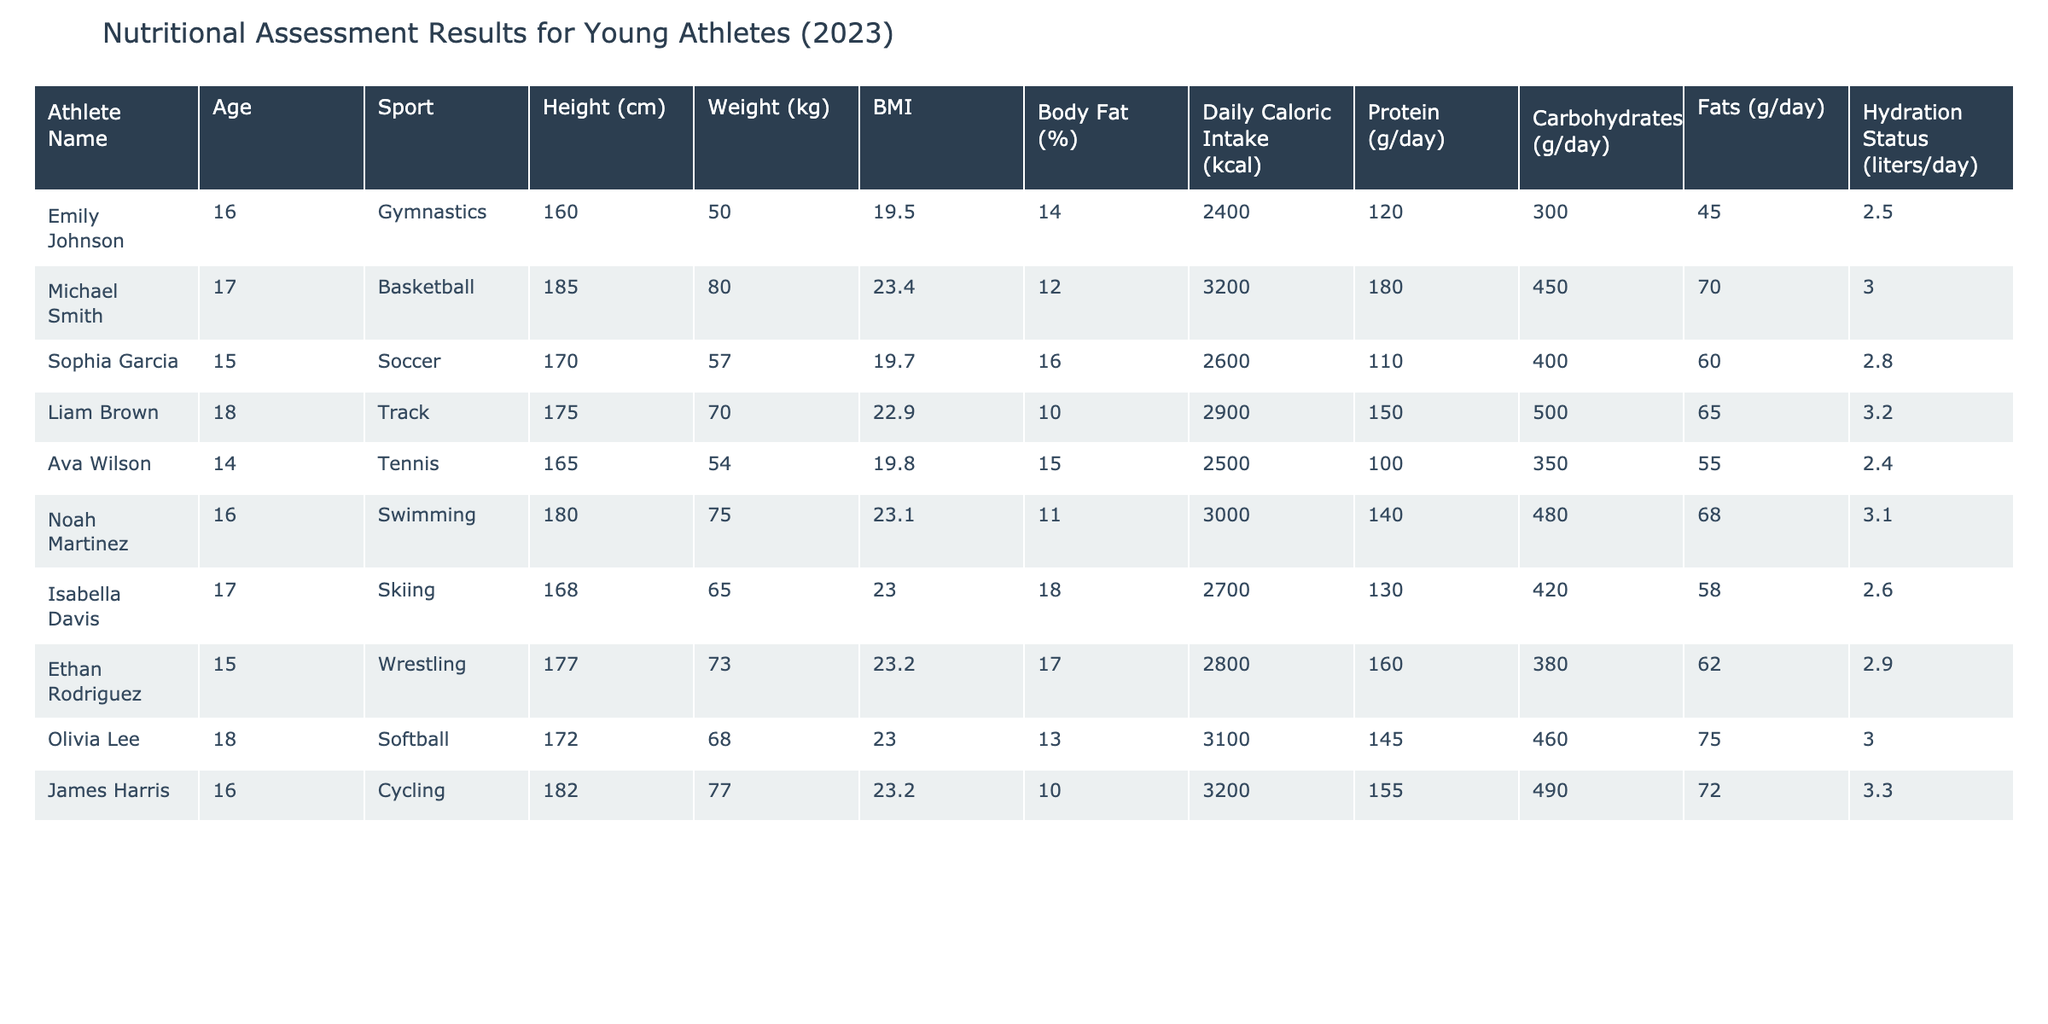What is the BMI of Noah Martinez? The BMI (Body Mass Index) is listed directly in the table for each athlete. For Noah Martinez, it is noted as 23.1.
Answer: 23.1 What is the average daily caloric intake for all athletes in the table? To find the average daily caloric intake, sum all the caloric intake values (2400 + 3200 + 2600 + 2900 + 2500 + 3000 + 2700 + 2800 + 3100 + 3200 =  27400) and divide by the number of athletes (10). The average is 27400 / 10 = 2740.
Answer: 2740 Do any athletes have a hydration status of more than 3 liters per day? By reviewing the hydration status column, I can see that both Michael Smith and James Harris have a hydration status of 3.0 and 3.3 liters respectively, which means they have more than 3 liters each. Thus, the answer is yes.
Answer: Yes Which athlete has the highest protein intake, and what is that value? Checking the protein intake values in the table, Ethan Rodriguez has the highest protein intake at 160 grams per day.
Answer: Ethan Rodriguez, 160 grams What is the average body fat percentage of the athletes in the table? To calculate the average body fat percentage, first sum all the body fat values (14 + 12 + 16 + 10 + 15 + 11 + 18 + 17 + 13 + 10 =  146). Then divide by the number of athletes (10): 146 / 10 = 14.6.
Answer: 14.6 Does the gymnast Emily Johnson have the lowest weight among the athletes? Comparing the weight of all athletes, Emily Johnson at 50 kg is indeed the lowest compared to the others like Michael Smith at 80 kg and Liam Brown at 70 kg. Thus, the statement is true.
Answer: Yes Which sport has the oldest athlete, and what is their age? The table indicates Liam Brown is the oldest athlete, at 18 years old, while checking the ages of all athletes confirms that.
Answer: Track, 18 years What is the total intake of carbohydrates for all the athletes combined? By summing the carbohydrate values listed (300 + 450 + 400 + 500 + 350 + 480 + 420 + 380 + 460 + 490 =  4020), the total carbohydrate intake is determined to be 4020 grams.
Answer: 4020 grams Which athlete's daily caloric intake is closest to the average daily caloric intake calculated earlier? Given our earlier average of 2740 kcal, upon examining the reflected daily caloric intakes, Emily Johnson has a caloric intake of 2400 which is closest to the average.
Answer: Emily Johnson, 2400 kcal 